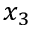Convert formula to latex. <formula><loc_0><loc_0><loc_500><loc_500>x _ { 3 }</formula> 